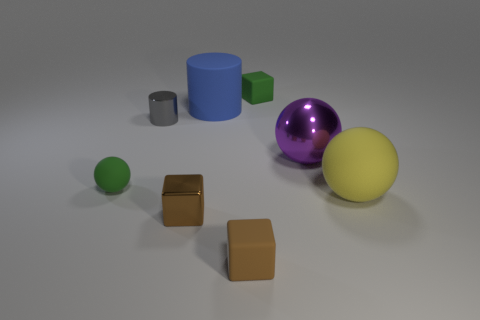Add 1 tiny green things. How many objects exist? 9 Subtract all blocks. How many objects are left? 5 Subtract 1 gray cylinders. How many objects are left? 7 Subtract all large yellow cylinders. Subtract all big matte cylinders. How many objects are left? 7 Add 7 tiny green rubber objects. How many tiny green rubber objects are left? 9 Add 1 large blue matte spheres. How many large blue matte spheres exist? 1 